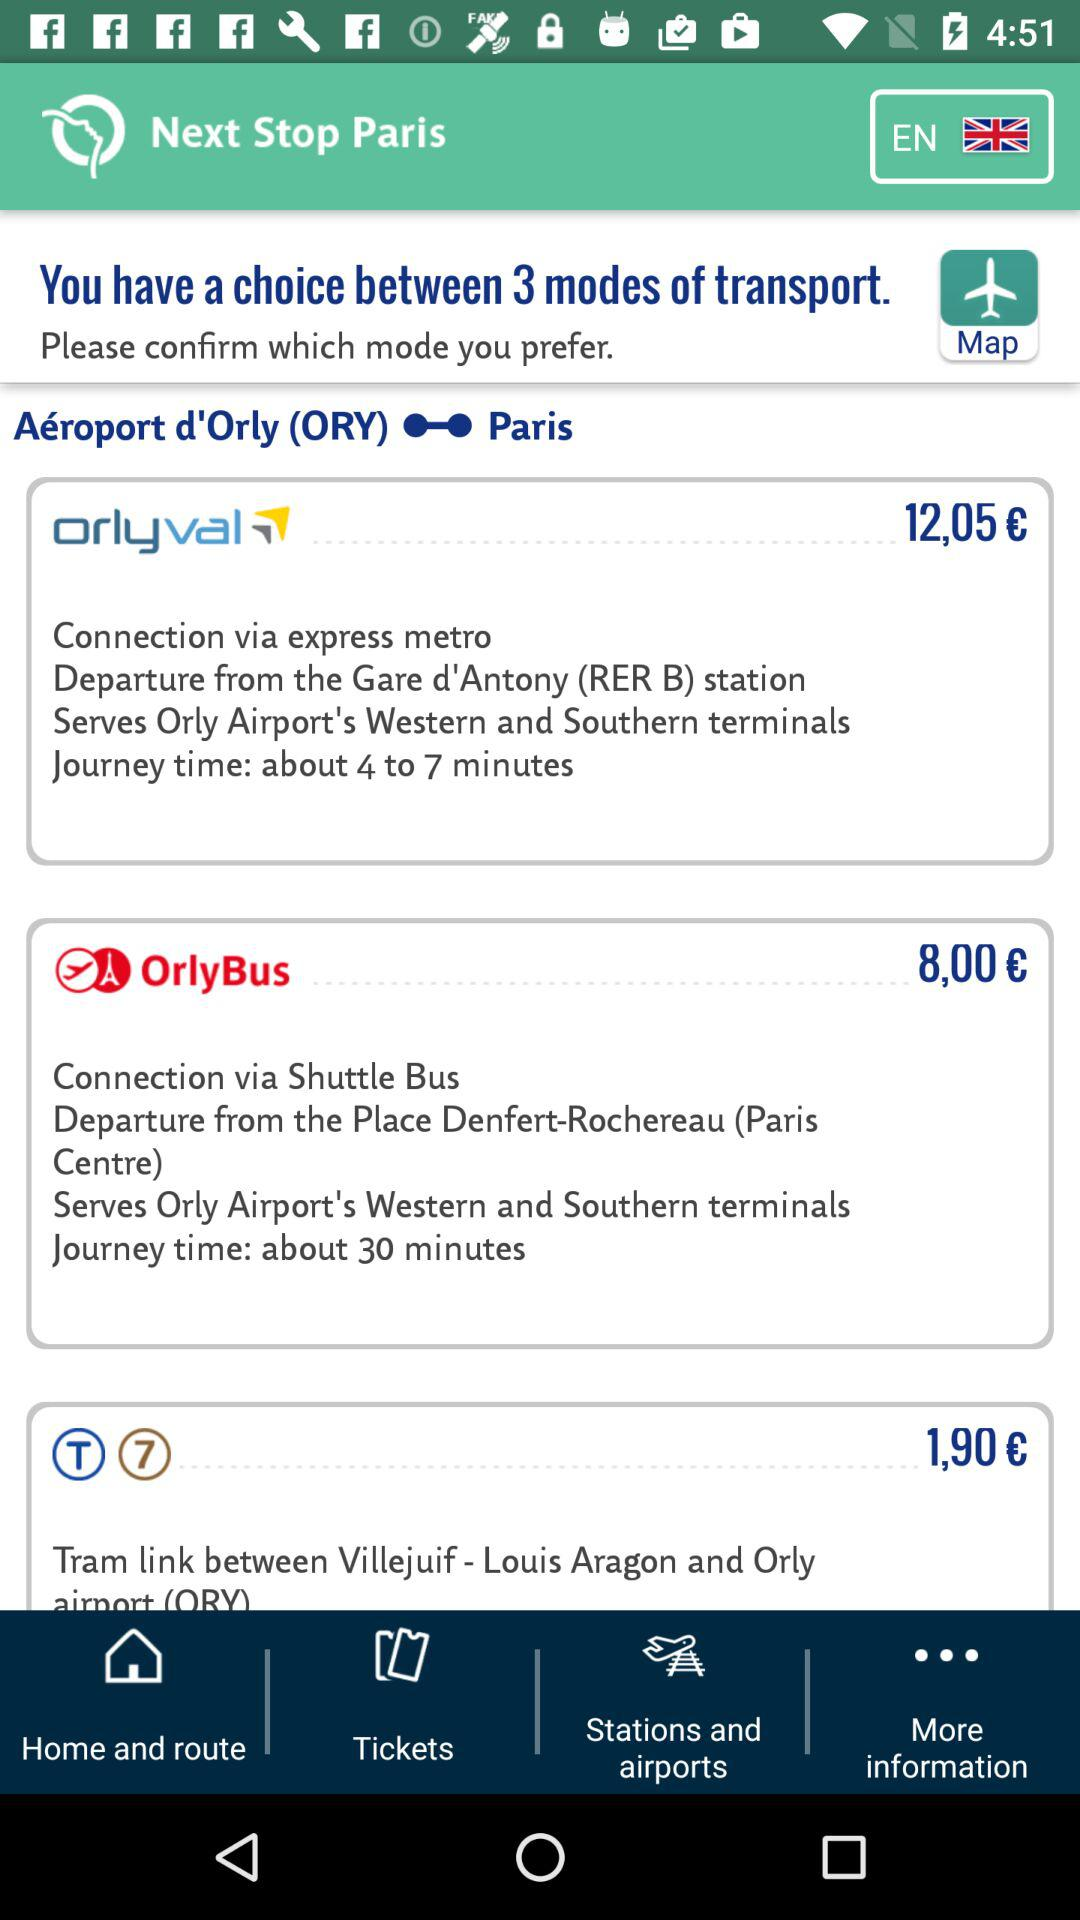What is the journey time of "orlyval"? The journey time is "about 4 to 7 minutes". 